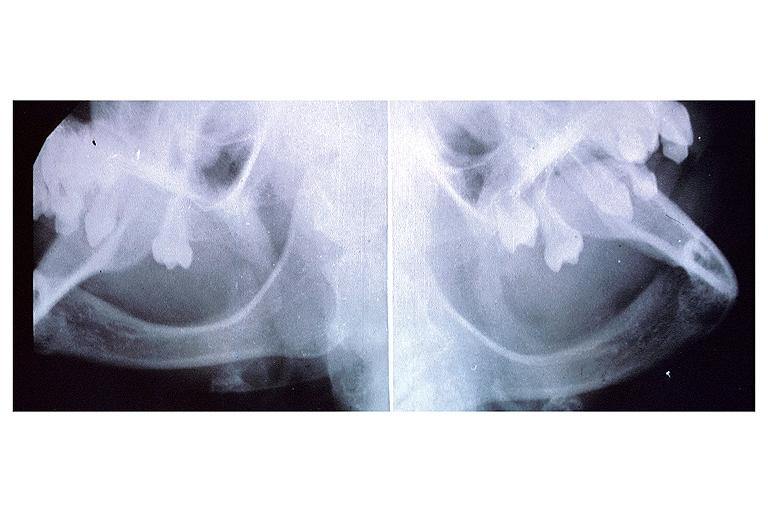s silver present?
Answer the question using a single word or phrase. No 